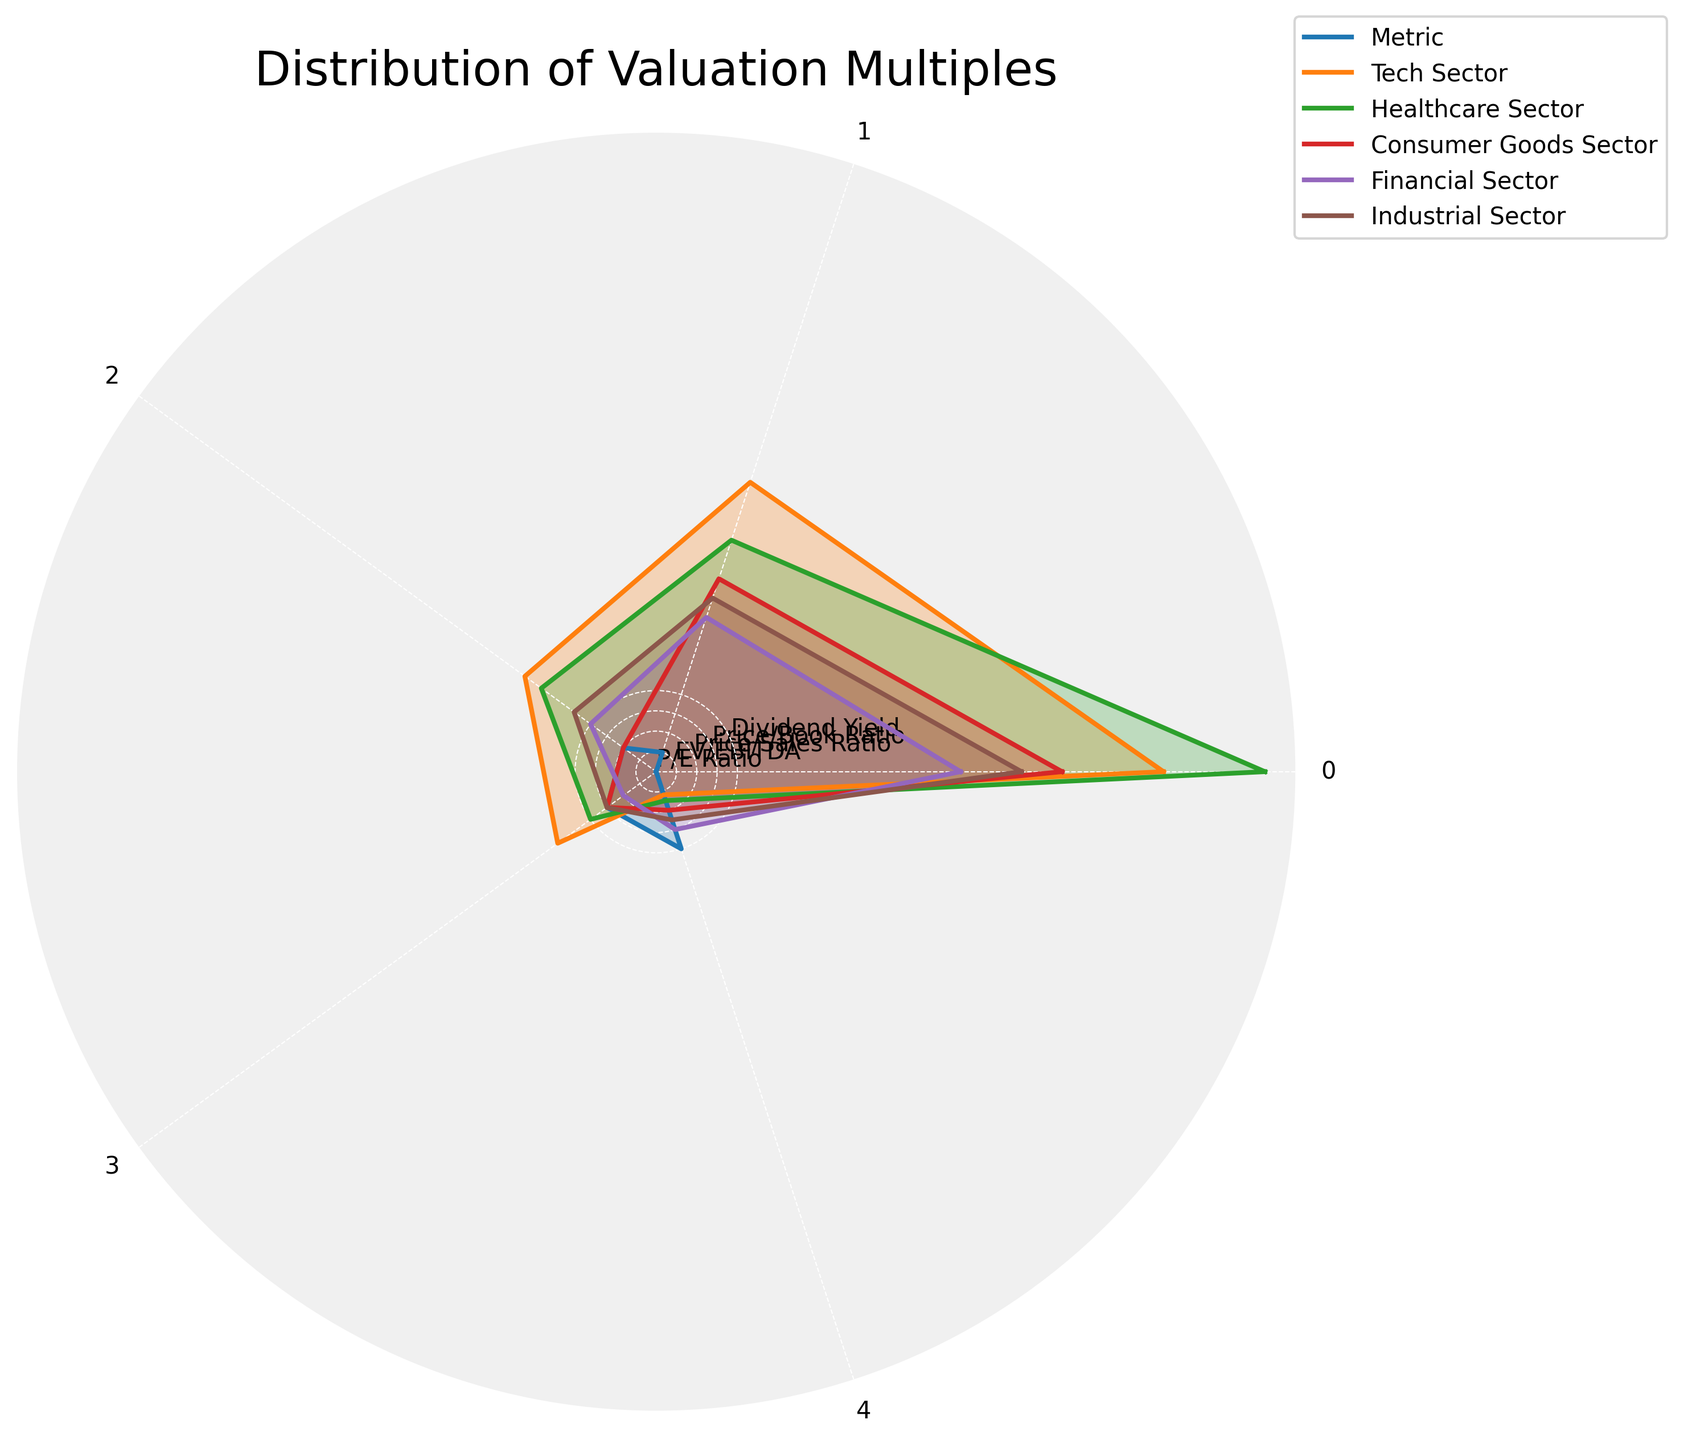What is the title of the chart? The title of the chart is displayed prominently at the top of the radar chart.
Answer: Distribution of Valuation Multiples Which sector has the highest Dividend Yield? By observing the Dividend Yield values for each sector, the Financial Sector has the highest value.
Answer: Financial Sector What is the average Price/Book Ratio across all sectors? To find the average, sum the Price/Book Ratios (6 + 4 + 3 + 2 + 3) = 18. Then divide by the number of sectors (5): 18 / 5 = 3.6
Answer: 3.6 Which sector shows the highest disparity between P/E Ratio and EV/EBITDA? By comparing the differences between P/E Ratio and EV/EBITDA for each sector: Tech (25-15=10), Healthcare (30-12=18), Consumer Goods (20-10=10), Financial (15-8=7), Industrial (18-9=9), Healthcare Sector has the highest disparity (18).
Answer: Healthcare Sector How does the Price/Sales Ratio of the Tech Sector compare to the Consumer Goods Sector? The Price/Sales Ratio for Tech Sector is 8 and for Consumer Goods is 2. 8 is greater than 2.
Answer: The Tech Sector has a higher Price/Sales Ratio If one were to invest based on high P/E Ratios and low Dividend Yields, which sector(s) would be most attractive? The Tech Sector, with a high P/E Ratio of 25 and a low Dividend Yield of 1.2, fits this criterion best.
Answer: Tech Sector Which sector has a Price/Book Ratio equal to the Industrial Sector's Price/Book Ratio? The Price/Book Ratio for the Industrial Sector is 3. Both the Consumer Goods and Industrial Sectors share the same value of 3.
Answer: Consumer Goods Sector What is the sum of the Dividend Yields across all sectors? By summing up the Dividend Yields (1.2 + 1.5 + 2.0 + 3.0 + 2.5) = 10.2.
Answer: 10.2 Compare the EV/EBITDA ratios for the Tech and Healthcare Sectors and find the difference. The EV/EBITDA for Tech is 15, while for Healthcare it is 12. The difference is 15 - 12 = 3.
Answer: 3 